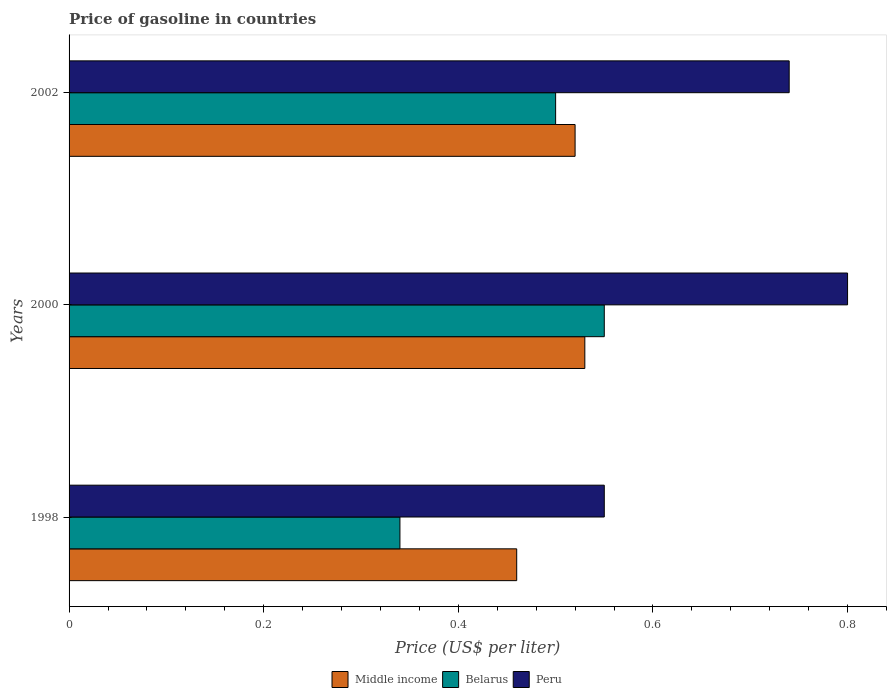How many groups of bars are there?
Keep it short and to the point. 3. Are the number of bars per tick equal to the number of legend labels?
Keep it short and to the point. Yes. Are the number of bars on each tick of the Y-axis equal?
Ensure brevity in your answer.  Yes. How many bars are there on the 3rd tick from the bottom?
Ensure brevity in your answer.  3. What is the label of the 2nd group of bars from the top?
Ensure brevity in your answer.  2000. In how many cases, is the number of bars for a given year not equal to the number of legend labels?
Your answer should be very brief. 0. What is the price of gasoline in Belarus in 2000?
Give a very brief answer. 0.55. Across all years, what is the maximum price of gasoline in Peru?
Provide a succinct answer. 0.8. Across all years, what is the minimum price of gasoline in Middle income?
Keep it short and to the point. 0.46. What is the total price of gasoline in Middle income in the graph?
Your answer should be very brief. 1.51. What is the difference between the price of gasoline in Middle income in 2000 and that in 2002?
Provide a short and direct response. 0.01. What is the difference between the price of gasoline in Belarus in 2000 and the price of gasoline in Peru in 2002?
Offer a terse response. -0.19. What is the average price of gasoline in Belarus per year?
Provide a short and direct response. 0.46. In the year 1998, what is the difference between the price of gasoline in Peru and price of gasoline in Middle income?
Your answer should be very brief. 0.09. In how many years, is the price of gasoline in Peru greater than 0.28 US$?
Provide a short and direct response. 3. What is the ratio of the price of gasoline in Middle income in 1998 to that in 2002?
Give a very brief answer. 0.88. Is the price of gasoline in Peru in 1998 less than that in 2002?
Ensure brevity in your answer.  Yes. Is the difference between the price of gasoline in Peru in 2000 and 2002 greater than the difference between the price of gasoline in Middle income in 2000 and 2002?
Your response must be concise. Yes. What is the difference between the highest and the second highest price of gasoline in Middle income?
Provide a succinct answer. 0.01. What is the difference between the highest and the lowest price of gasoline in Middle income?
Offer a very short reply. 0.07. Is the sum of the price of gasoline in Middle income in 2000 and 2002 greater than the maximum price of gasoline in Peru across all years?
Your response must be concise. Yes. What does the 2nd bar from the top in 1998 represents?
Make the answer very short. Belarus. Is it the case that in every year, the sum of the price of gasoline in Middle income and price of gasoline in Belarus is greater than the price of gasoline in Peru?
Offer a very short reply. Yes. Are the values on the major ticks of X-axis written in scientific E-notation?
Your response must be concise. No. How many legend labels are there?
Provide a succinct answer. 3. How are the legend labels stacked?
Provide a short and direct response. Horizontal. What is the title of the graph?
Ensure brevity in your answer.  Price of gasoline in countries. What is the label or title of the X-axis?
Ensure brevity in your answer.  Price (US$ per liter). What is the label or title of the Y-axis?
Keep it short and to the point. Years. What is the Price (US$ per liter) in Middle income in 1998?
Provide a succinct answer. 0.46. What is the Price (US$ per liter) in Belarus in 1998?
Make the answer very short. 0.34. What is the Price (US$ per liter) of Peru in 1998?
Keep it short and to the point. 0.55. What is the Price (US$ per liter) of Middle income in 2000?
Provide a succinct answer. 0.53. What is the Price (US$ per liter) of Belarus in 2000?
Give a very brief answer. 0.55. What is the Price (US$ per liter) of Middle income in 2002?
Your response must be concise. 0.52. What is the Price (US$ per liter) of Peru in 2002?
Your answer should be compact. 0.74. Across all years, what is the maximum Price (US$ per liter) in Middle income?
Ensure brevity in your answer.  0.53. Across all years, what is the maximum Price (US$ per liter) of Belarus?
Provide a short and direct response. 0.55. Across all years, what is the minimum Price (US$ per liter) of Middle income?
Provide a succinct answer. 0.46. Across all years, what is the minimum Price (US$ per liter) of Belarus?
Ensure brevity in your answer.  0.34. Across all years, what is the minimum Price (US$ per liter) of Peru?
Give a very brief answer. 0.55. What is the total Price (US$ per liter) in Middle income in the graph?
Provide a succinct answer. 1.51. What is the total Price (US$ per liter) of Belarus in the graph?
Make the answer very short. 1.39. What is the total Price (US$ per liter) of Peru in the graph?
Your response must be concise. 2.09. What is the difference between the Price (US$ per liter) in Middle income in 1998 and that in 2000?
Provide a succinct answer. -0.07. What is the difference between the Price (US$ per liter) of Belarus in 1998 and that in 2000?
Make the answer very short. -0.21. What is the difference between the Price (US$ per liter) in Peru in 1998 and that in 2000?
Your response must be concise. -0.25. What is the difference between the Price (US$ per liter) in Middle income in 1998 and that in 2002?
Provide a succinct answer. -0.06. What is the difference between the Price (US$ per liter) of Belarus in 1998 and that in 2002?
Give a very brief answer. -0.16. What is the difference between the Price (US$ per liter) of Peru in 1998 and that in 2002?
Offer a very short reply. -0.19. What is the difference between the Price (US$ per liter) in Middle income in 1998 and the Price (US$ per liter) in Belarus in 2000?
Provide a succinct answer. -0.09. What is the difference between the Price (US$ per liter) of Middle income in 1998 and the Price (US$ per liter) of Peru in 2000?
Offer a very short reply. -0.34. What is the difference between the Price (US$ per liter) in Belarus in 1998 and the Price (US$ per liter) in Peru in 2000?
Your answer should be compact. -0.46. What is the difference between the Price (US$ per liter) of Middle income in 1998 and the Price (US$ per liter) of Belarus in 2002?
Offer a very short reply. -0.04. What is the difference between the Price (US$ per liter) in Middle income in 1998 and the Price (US$ per liter) in Peru in 2002?
Offer a terse response. -0.28. What is the difference between the Price (US$ per liter) of Belarus in 1998 and the Price (US$ per liter) of Peru in 2002?
Make the answer very short. -0.4. What is the difference between the Price (US$ per liter) of Middle income in 2000 and the Price (US$ per liter) of Belarus in 2002?
Give a very brief answer. 0.03. What is the difference between the Price (US$ per liter) in Middle income in 2000 and the Price (US$ per liter) in Peru in 2002?
Your response must be concise. -0.21. What is the difference between the Price (US$ per liter) in Belarus in 2000 and the Price (US$ per liter) in Peru in 2002?
Provide a succinct answer. -0.19. What is the average Price (US$ per liter) in Middle income per year?
Give a very brief answer. 0.5. What is the average Price (US$ per liter) of Belarus per year?
Offer a very short reply. 0.46. What is the average Price (US$ per liter) in Peru per year?
Offer a very short reply. 0.7. In the year 1998, what is the difference between the Price (US$ per liter) in Middle income and Price (US$ per liter) in Belarus?
Keep it short and to the point. 0.12. In the year 1998, what is the difference between the Price (US$ per liter) of Middle income and Price (US$ per liter) of Peru?
Give a very brief answer. -0.09. In the year 1998, what is the difference between the Price (US$ per liter) of Belarus and Price (US$ per liter) of Peru?
Ensure brevity in your answer.  -0.21. In the year 2000, what is the difference between the Price (US$ per liter) of Middle income and Price (US$ per liter) of Belarus?
Ensure brevity in your answer.  -0.02. In the year 2000, what is the difference between the Price (US$ per liter) in Middle income and Price (US$ per liter) in Peru?
Give a very brief answer. -0.27. In the year 2002, what is the difference between the Price (US$ per liter) of Middle income and Price (US$ per liter) of Belarus?
Make the answer very short. 0.02. In the year 2002, what is the difference between the Price (US$ per liter) of Middle income and Price (US$ per liter) of Peru?
Provide a succinct answer. -0.22. In the year 2002, what is the difference between the Price (US$ per liter) of Belarus and Price (US$ per liter) of Peru?
Ensure brevity in your answer.  -0.24. What is the ratio of the Price (US$ per liter) in Middle income in 1998 to that in 2000?
Keep it short and to the point. 0.87. What is the ratio of the Price (US$ per liter) of Belarus in 1998 to that in 2000?
Offer a terse response. 0.62. What is the ratio of the Price (US$ per liter) of Peru in 1998 to that in 2000?
Ensure brevity in your answer.  0.69. What is the ratio of the Price (US$ per liter) in Middle income in 1998 to that in 2002?
Offer a terse response. 0.88. What is the ratio of the Price (US$ per liter) in Belarus in 1998 to that in 2002?
Ensure brevity in your answer.  0.68. What is the ratio of the Price (US$ per liter) of Peru in 1998 to that in 2002?
Your response must be concise. 0.74. What is the ratio of the Price (US$ per liter) in Middle income in 2000 to that in 2002?
Your answer should be compact. 1.02. What is the ratio of the Price (US$ per liter) in Belarus in 2000 to that in 2002?
Ensure brevity in your answer.  1.1. What is the ratio of the Price (US$ per liter) of Peru in 2000 to that in 2002?
Your answer should be very brief. 1.08. What is the difference between the highest and the second highest Price (US$ per liter) of Peru?
Offer a terse response. 0.06. What is the difference between the highest and the lowest Price (US$ per liter) in Middle income?
Keep it short and to the point. 0.07. What is the difference between the highest and the lowest Price (US$ per liter) of Belarus?
Give a very brief answer. 0.21. 